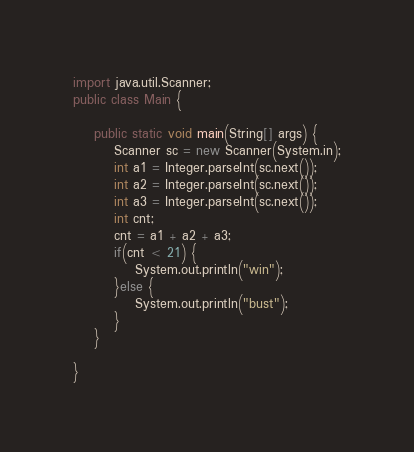Convert code to text. <code><loc_0><loc_0><loc_500><loc_500><_Java_>import java.util.Scanner;
public class Main {

	public static void main(String[] args) {
		Scanner sc = new Scanner(System.in);
		int a1 = Integer.parseInt(sc.next());
		int a2 = Integer.parseInt(sc.next());
		int a3 = Integer.parseInt(sc.next());
		int cnt;
		cnt = a1 + a2 + a3;
		if(cnt < 21) {
			System.out.println("win");
		}else {
			System.out.println("bust");
		}
	}

}
</code> 